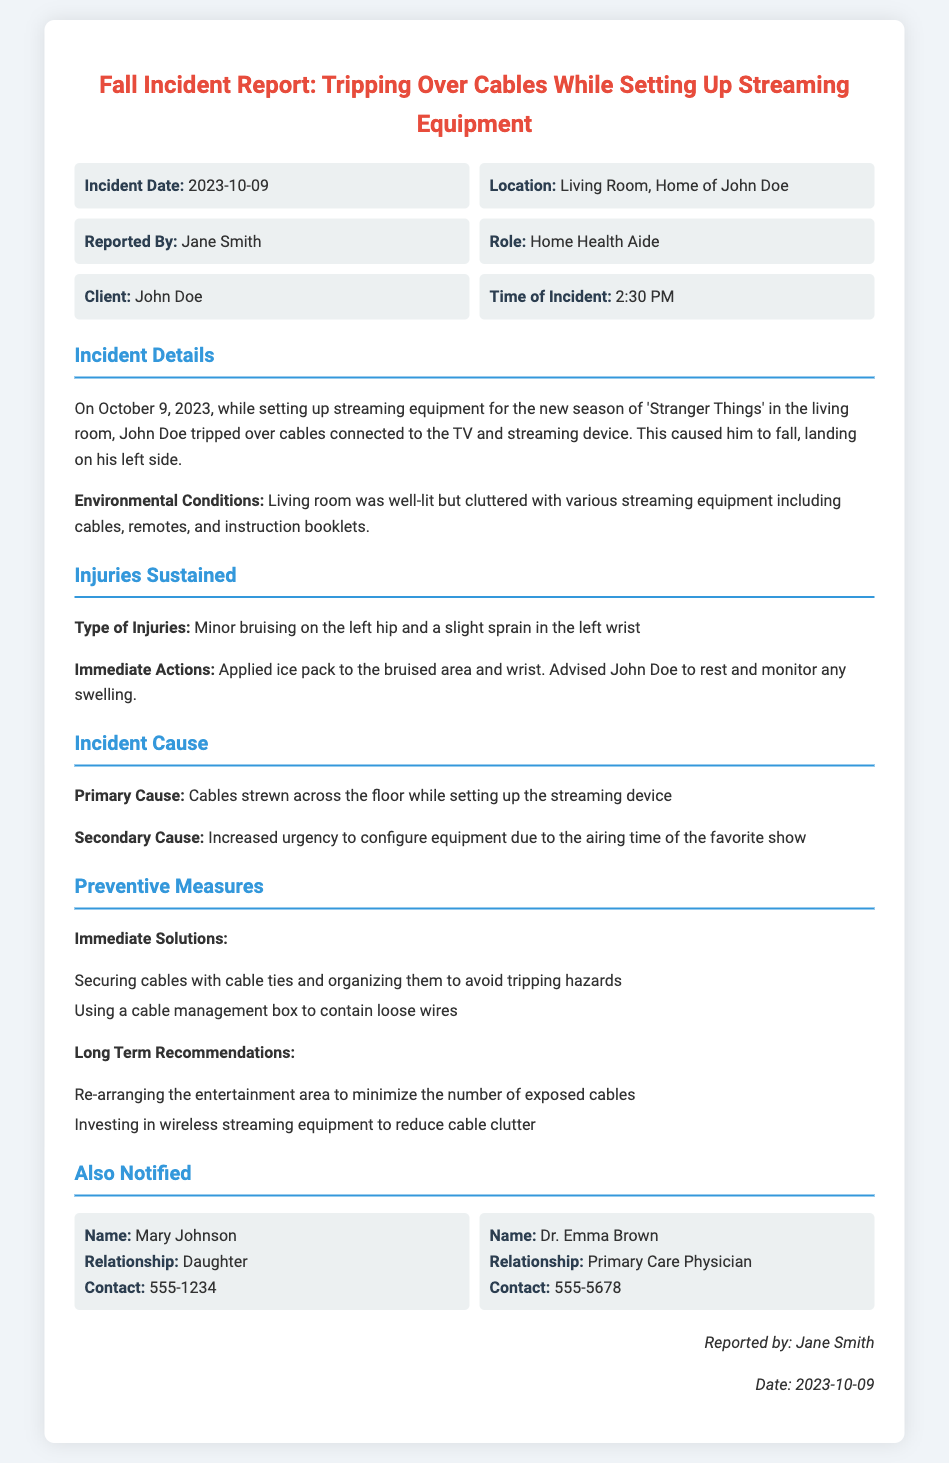What was the incident date? The incident date is specified in the document as October 9, 2023.
Answer: October 9, 2023 Where did the incident occur? The location of the incident is identified as the living room in the home of John Doe.
Answer: Living Room, Home of John Doe Who reported the incident? The document notes that the incident was reported by Jane Smith.
Answer: Jane Smith What type of injuries were sustained? The report describes the injuries as minor bruising on the left hip and a slight sprain in the left wrist.
Answer: Minor bruising on the left hip and a slight sprain in the left wrist What was the primary cause of the incident? The primary cause is detailed in the document, referring to cables strewn across the floor while setting up the streaming device.
Answer: Cables strewn across the floor What actions were taken immediately after the incident? The immediate actions taken included applying ice packs to the bruised area and wrist and advising rest.
Answer: Applied ice pack to the bruised area and wrist Which show was being set up equipment for? The document indicates that the streaming equipment was being set up for the new season of 'Stranger Things.'
Answer: 'Stranger Things' What is one immediate solution to prevent future incidents? The document lists securing cables with cable ties as one immediate solution to avoid tripping hazards.
Answer: Securing cables with cable ties Who was notified about the incident? The document specifies that Mary Johnson, the daughter, and Dr. Emma Brown, the primary care physician, were notified.
Answer: Mary Johnson and Dr. Emma Brown 